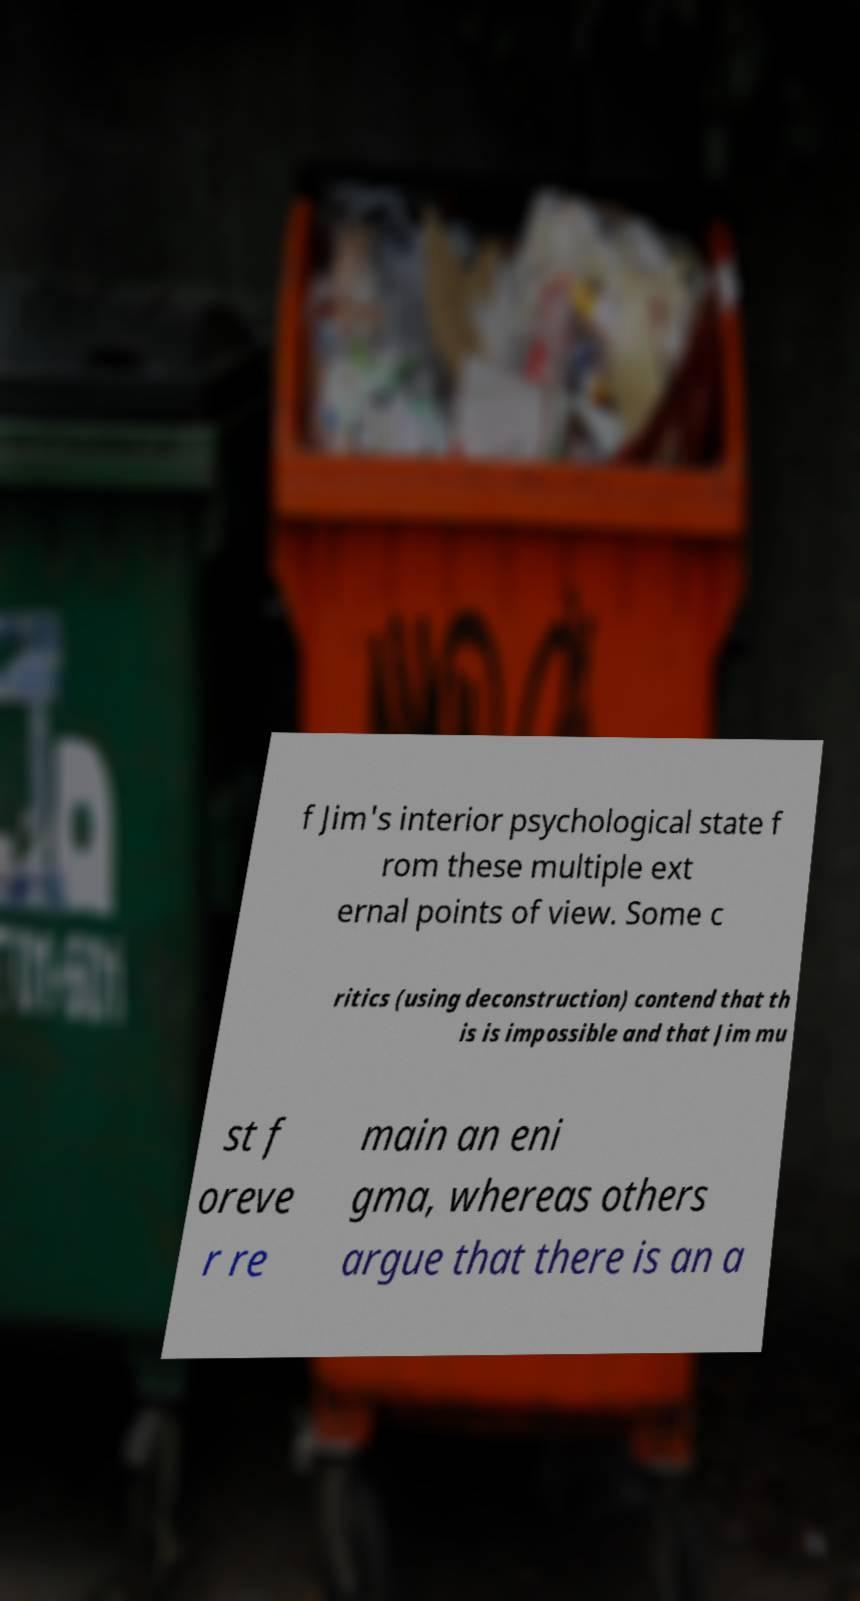Please identify and transcribe the text found in this image. f Jim's interior psychological state f rom these multiple ext ernal points of view. Some c ritics (using deconstruction) contend that th is is impossible and that Jim mu st f oreve r re main an eni gma, whereas others argue that there is an a 